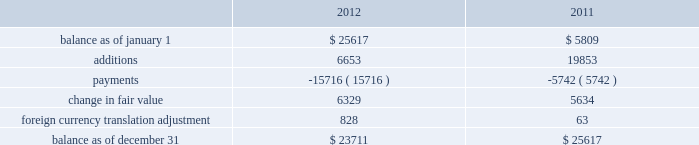American tower corporation and subsidiaries notes to consolidated financial statements related contingent consideration , and any subsequent changes in fair value using a discounted probability- weighted approach .
This approach takes into consideration level 3 unobservable inputs including probability assessments of expected future cash flows over the period in which the obligation is expected to be settled and applies a discount factor that captures the uncertainties associated with the obligation .
Changes in these unobservable inputs could significantly impact the fair value of the liabilities recorded in the accompanying consolidated balance sheets and operating expenses in the consolidated statements of operations .
As of december 31 , 2012 , the company estimates the value of all potential acquisition-related contingent consideration required payments to be between zero and $ 43.6 million .
During the years ended december 31 , 2012 and 2011 , the fair value of the contingent consideration changed as follows ( in thousands ) : .
Items measured at fair value on a nonrecurring basis 2014during the year ended december 31 , 2012 , certain long-lived assets held and used with a carrying value of $ 5379.2 million were written down to their net realizable value of $ 5357.7 million as a result of an asset impairment charge of $ 21.5 million , which was recorded in other operating expenses in the accompanying consolidated statements of operations .
During the year ended december 31 , 2011 , long-lived assets held and used with a carrying value of $ 4280.8 million were written down to their net realizable value of $ 4271.8 million , resulting in an asset impairment charge of $ 9.0 million .
These adjustments were determined by comparing the estimated proceeds from sale of assets or the projected future discounted cash flows to be provided from the long-lived assets ( calculated using level 3 inputs ) to the asset 2019s carrying value .
There were no other items measured at fair value on a nonrecurring basis during the year ended december 31 , 2012 .
Fair value of financial instruments 2014the carrying value of the company 2019s financial instruments , with the exception of long-term obligations , including the current portion , reasonably approximate the related fair value as of december 31 , 2012 and 2011 .
The company 2019s estimates of fair value of its long-term obligations , including the current portion , are based primarily upon reported market values .
For long-term debt not actively traded , fair value was estimated using a discounted cash flow analysis using rates for debt with similar terms and maturities .
As of december 31 , 2012 , the carrying value and fair value of long-term obligations , including the current portion , were $ 8.8 billion and $ 9.4 billion , respectively , of which $ 4.9 billion was measured using level 1 inputs and $ 4.5 billion was measured using level 2 inputs .
As of december 31 , 2011 , the carrying value and fair value of long-term obligations , including the current portion , were $ 7.2 billion and $ 7.5 billion , respectively , of which $ 3.8 billion was measured using level 1 inputs and $ 3.7 billion was measured using level 2 inputs .
13 .
Income taxes the company has filed , for prior taxable years through its taxable year ended december 31 , 2011 , a consolidated u.s .
Federal tax return , which includes all of its wholly owned domestic subsidiaries .
For its taxable year commencing january 1 , 2012 , the company intends to file as a reit , and its domestic trss intend to file as c corporations .
The company also files tax returns in various states and countries .
The company 2019s state tax returns reflect different combinations of the company 2019s subsidiaries and are dependent on the connection each subsidiary has with a particular state .
The following information pertains to the company 2019s income taxes on a consolidated basis. .
Level 1 inputs are generally more accurate than level 2 . in 2012 , what percentage of long-term obligations , was not measured using level 1 inputs? 
Computations: (4.5 / 9.4)
Answer: 0.47872. American tower corporation and subsidiaries notes to consolidated financial statements related contingent consideration , and any subsequent changes in fair value using a discounted probability- weighted approach .
This approach takes into consideration level 3 unobservable inputs including probability assessments of expected future cash flows over the period in which the obligation is expected to be settled and applies a discount factor that captures the uncertainties associated with the obligation .
Changes in these unobservable inputs could significantly impact the fair value of the liabilities recorded in the accompanying consolidated balance sheets and operating expenses in the consolidated statements of operations .
As of december 31 , 2012 , the company estimates the value of all potential acquisition-related contingent consideration required payments to be between zero and $ 43.6 million .
During the years ended december 31 , 2012 and 2011 , the fair value of the contingent consideration changed as follows ( in thousands ) : .
Items measured at fair value on a nonrecurring basis 2014during the year ended december 31 , 2012 , certain long-lived assets held and used with a carrying value of $ 5379.2 million were written down to their net realizable value of $ 5357.7 million as a result of an asset impairment charge of $ 21.5 million , which was recorded in other operating expenses in the accompanying consolidated statements of operations .
During the year ended december 31 , 2011 , long-lived assets held and used with a carrying value of $ 4280.8 million were written down to their net realizable value of $ 4271.8 million , resulting in an asset impairment charge of $ 9.0 million .
These adjustments were determined by comparing the estimated proceeds from sale of assets or the projected future discounted cash flows to be provided from the long-lived assets ( calculated using level 3 inputs ) to the asset 2019s carrying value .
There were no other items measured at fair value on a nonrecurring basis during the year ended december 31 , 2012 .
Fair value of financial instruments 2014the carrying value of the company 2019s financial instruments , with the exception of long-term obligations , including the current portion , reasonably approximate the related fair value as of december 31 , 2012 and 2011 .
The company 2019s estimates of fair value of its long-term obligations , including the current portion , are based primarily upon reported market values .
For long-term debt not actively traded , fair value was estimated using a discounted cash flow analysis using rates for debt with similar terms and maturities .
As of december 31 , 2012 , the carrying value and fair value of long-term obligations , including the current portion , were $ 8.8 billion and $ 9.4 billion , respectively , of which $ 4.9 billion was measured using level 1 inputs and $ 4.5 billion was measured using level 2 inputs .
As of december 31 , 2011 , the carrying value and fair value of long-term obligations , including the current portion , were $ 7.2 billion and $ 7.5 billion , respectively , of which $ 3.8 billion was measured using level 1 inputs and $ 3.7 billion was measured using level 2 inputs .
13 .
Income taxes the company has filed , for prior taxable years through its taxable year ended december 31 , 2011 , a consolidated u.s .
Federal tax return , which includes all of its wholly owned domestic subsidiaries .
For its taxable year commencing january 1 , 2012 , the company intends to file as a reit , and its domestic trss intend to file as c corporations .
The company also files tax returns in various states and countries .
The company 2019s state tax returns reflect different combinations of the company 2019s subsidiaries and are dependent on the connection each subsidiary has with a particular state .
The following information pertains to the company 2019s income taxes on a consolidated basis. .
What was the improvement in non-recurring items relating to impairments from 2011 to 2012 , in millions? 
Computations: (21.5 - 9.0)
Answer: 12.5. 